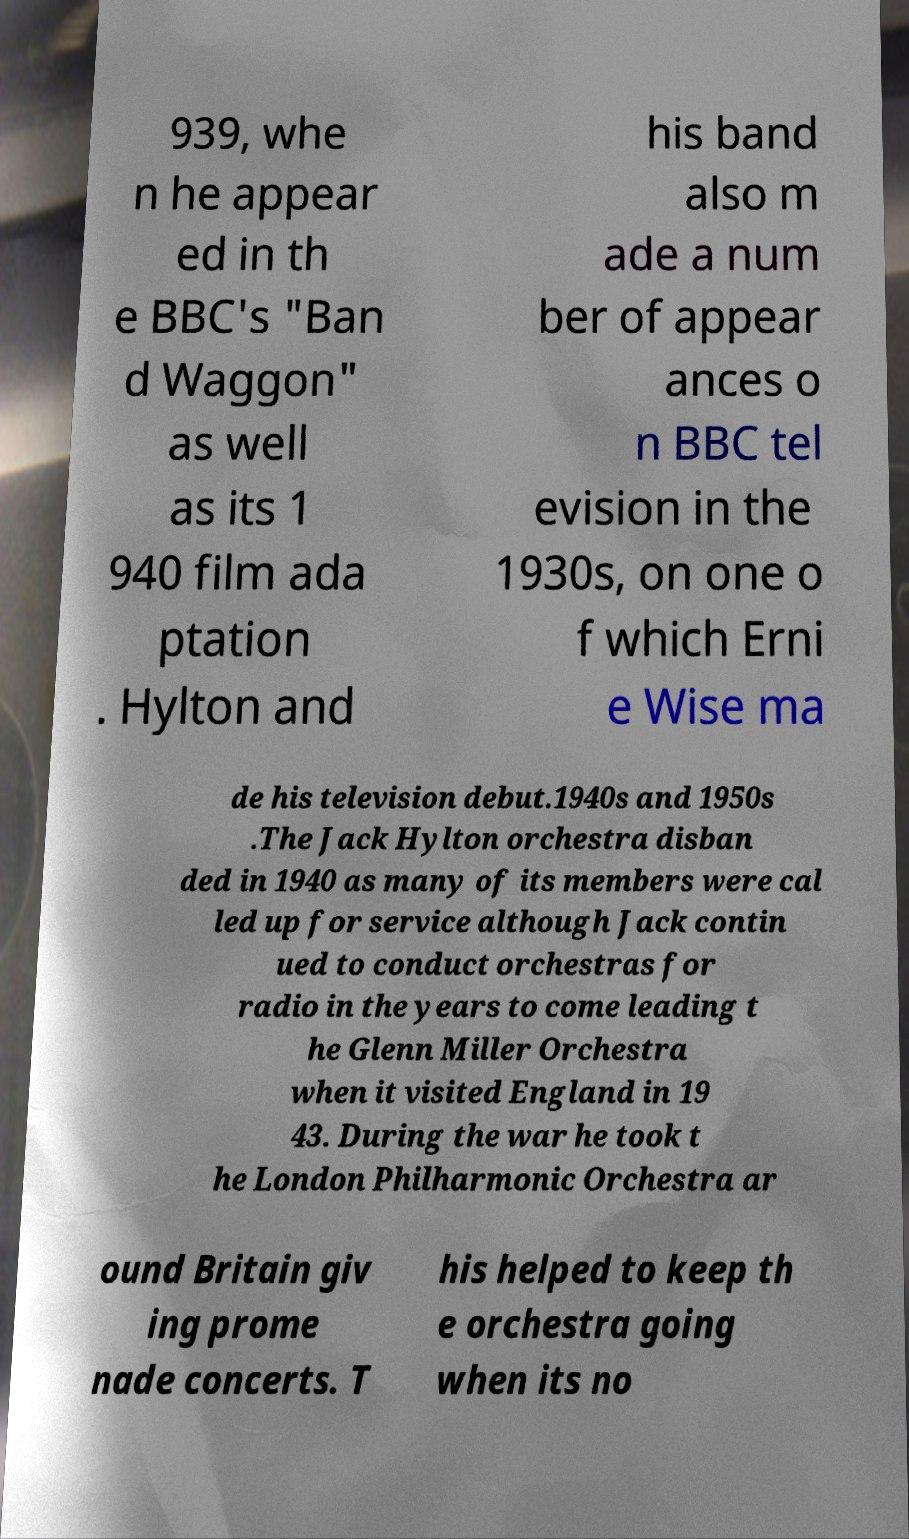There's text embedded in this image that I need extracted. Can you transcribe it verbatim? 939, whe n he appear ed in th e BBC's "Ban d Waggon" as well as its 1 940 film ada ptation . Hylton and his band also m ade a num ber of appear ances o n BBC tel evision in the 1930s, on one o f which Erni e Wise ma de his television debut.1940s and 1950s .The Jack Hylton orchestra disban ded in 1940 as many of its members were cal led up for service although Jack contin ued to conduct orchestras for radio in the years to come leading t he Glenn Miller Orchestra when it visited England in 19 43. During the war he took t he London Philharmonic Orchestra ar ound Britain giv ing prome nade concerts. T his helped to keep th e orchestra going when its no 